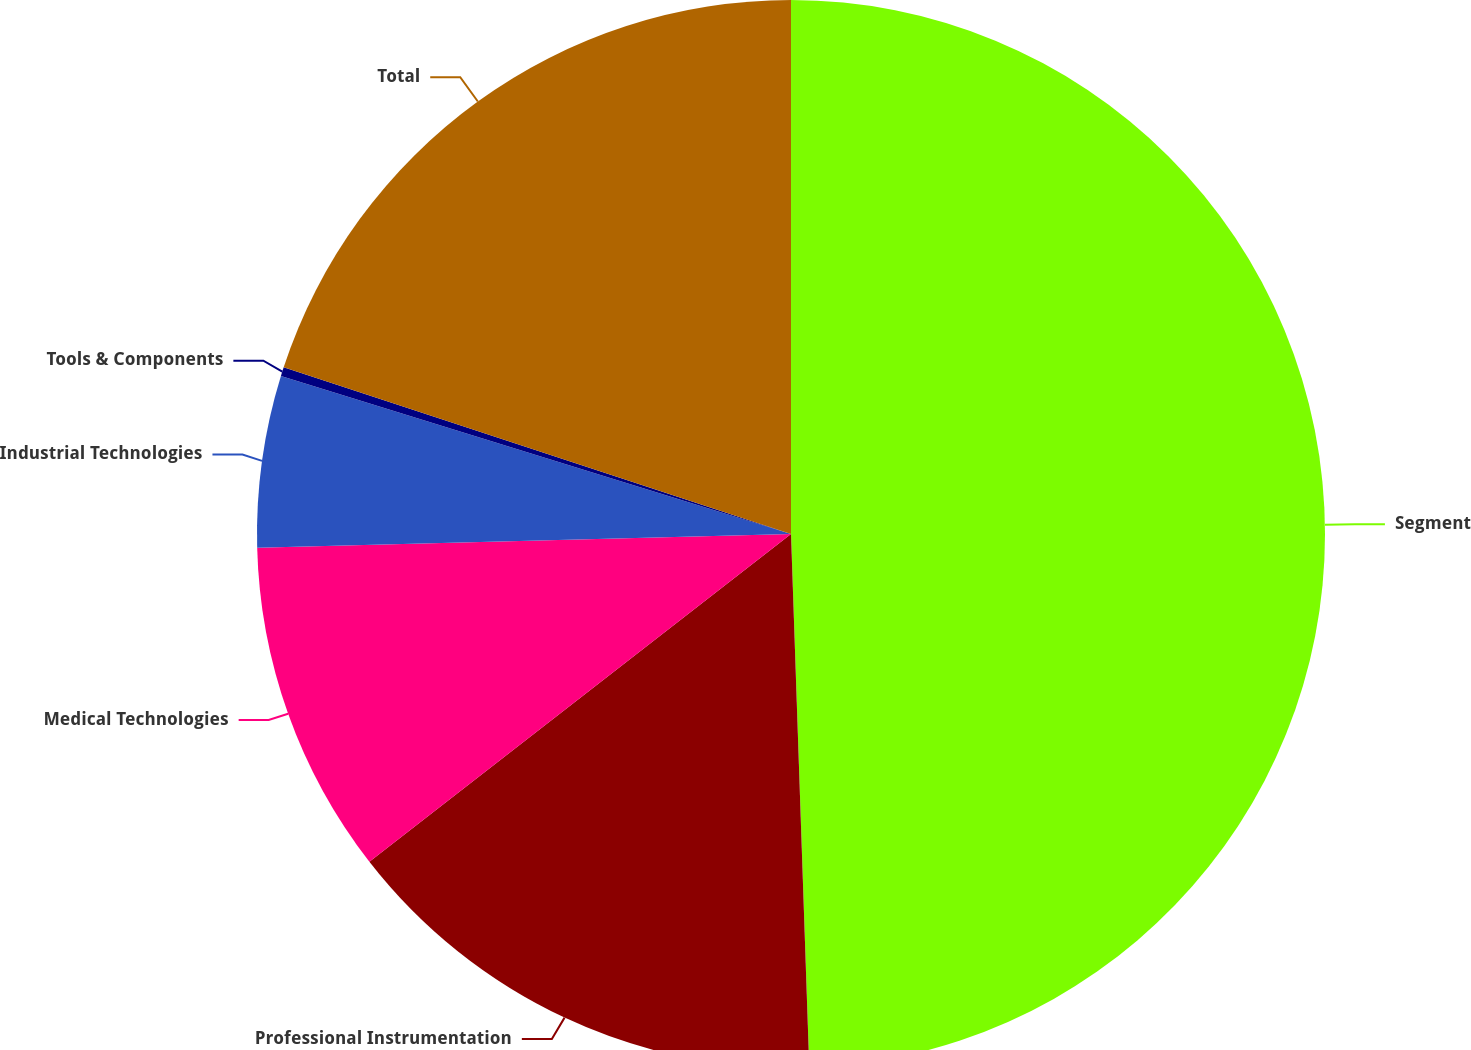<chart> <loc_0><loc_0><loc_500><loc_500><pie_chart><fcel>Segment<fcel>Professional Instrumentation<fcel>Medical Technologies<fcel>Industrial Technologies<fcel>Tools & Components<fcel>Total<nl><fcel>49.46%<fcel>15.03%<fcel>10.11%<fcel>5.19%<fcel>0.27%<fcel>19.95%<nl></chart> 